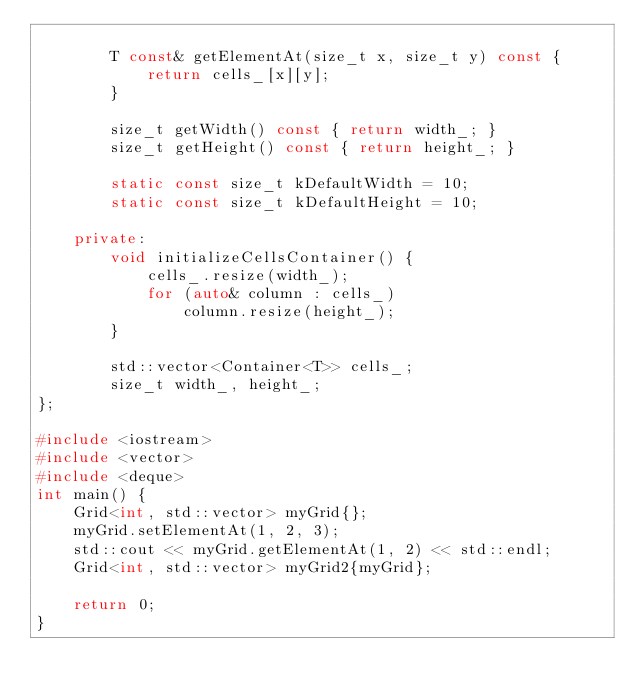<code> <loc_0><loc_0><loc_500><loc_500><_C++_>
        T const& getElementAt(size_t x, size_t y) const {
            return cells_[x][y];
        }

        size_t getWidth() const { return width_; }
        size_t getHeight() const { return height_; }

        static const size_t kDefaultWidth = 10;
        static const size_t kDefaultHeight = 10;

    private:
        void initializeCellsContainer() {
            cells_.resize(width_);
            for (auto& column : cells_)
                column.resize(height_);
        }

        std::vector<Container<T>> cells_;
        size_t width_, height_;
};

#include <iostream>
#include <vector>
#include <deque>
int main() {
    Grid<int, std::vector> myGrid{};
    myGrid.setElementAt(1, 2, 3);
    std::cout << myGrid.getElementAt(1, 2) << std::endl;
    Grid<int, std::vector> myGrid2{myGrid};

    return 0;
}
</code> 